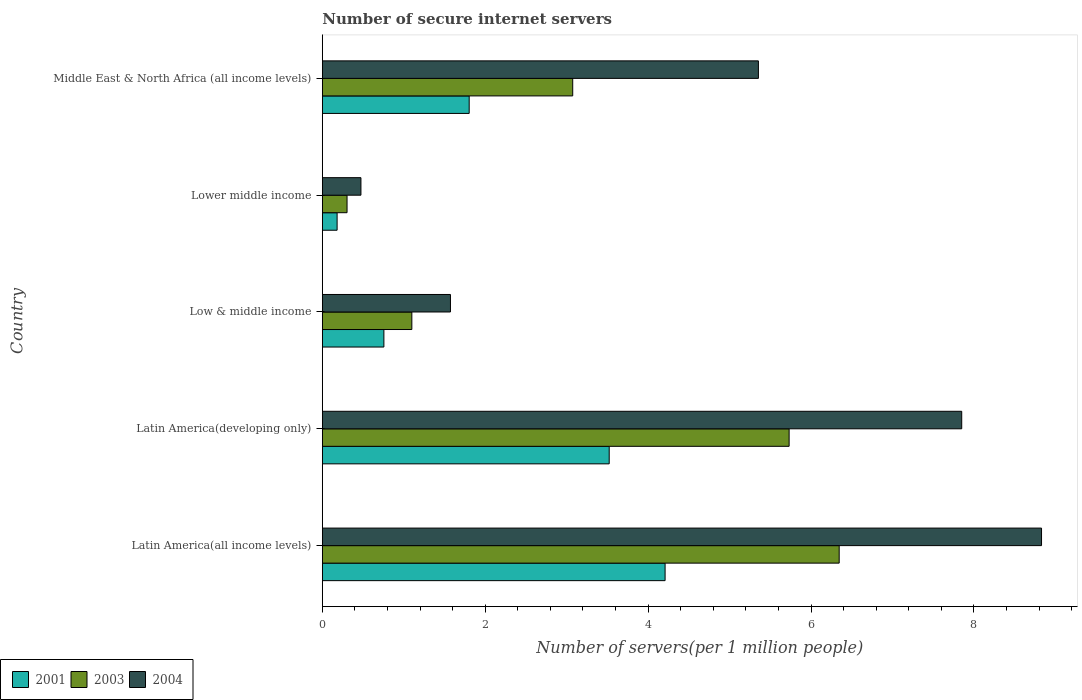How many groups of bars are there?
Provide a succinct answer. 5. Are the number of bars per tick equal to the number of legend labels?
Provide a succinct answer. Yes. Are the number of bars on each tick of the Y-axis equal?
Ensure brevity in your answer.  Yes. How many bars are there on the 3rd tick from the bottom?
Your answer should be compact. 3. What is the label of the 5th group of bars from the top?
Ensure brevity in your answer.  Latin America(all income levels). What is the number of secure internet servers in 2001 in Middle East & North Africa (all income levels)?
Offer a terse response. 1.8. Across all countries, what is the maximum number of secure internet servers in 2004?
Your answer should be compact. 8.83. Across all countries, what is the minimum number of secure internet servers in 2001?
Your answer should be very brief. 0.18. In which country was the number of secure internet servers in 2001 maximum?
Give a very brief answer. Latin America(all income levels). In which country was the number of secure internet servers in 2003 minimum?
Keep it short and to the point. Lower middle income. What is the total number of secure internet servers in 2004 in the graph?
Keep it short and to the point. 24.08. What is the difference between the number of secure internet servers in 2003 in Latin America(all income levels) and that in Latin America(developing only)?
Ensure brevity in your answer.  0.61. What is the difference between the number of secure internet servers in 2003 in Lower middle income and the number of secure internet servers in 2001 in Latin America(developing only)?
Your answer should be very brief. -3.22. What is the average number of secure internet servers in 2001 per country?
Your answer should be very brief. 2.09. What is the difference between the number of secure internet servers in 2004 and number of secure internet servers in 2001 in Low & middle income?
Provide a short and direct response. 0.82. In how many countries, is the number of secure internet servers in 2003 greater than 4 ?
Keep it short and to the point. 2. What is the ratio of the number of secure internet servers in 2001 in Low & middle income to that in Lower middle income?
Offer a very short reply. 4.16. Is the number of secure internet servers in 2003 in Latin America(all income levels) less than that in Lower middle income?
Give a very brief answer. No. Is the difference between the number of secure internet servers in 2004 in Low & middle income and Middle East & North Africa (all income levels) greater than the difference between the number of secure internet servers in 2001 in Low & middle income and Middle East & North Africa (all income levels)?
Provide a succinct answer. No. What is the difference between the highest and the second highest number of secure internet servers in 2003?
Offer a very short reply. 0.61. What is the difference between the highest and the lowest number of secure internet servers in 2004?
Keep it short and to the point. 8.36. Is the sum of the number of secure internet servers in 2004 in Latin America(developing only) and Lower middle income greater than the maximum number of secure internet servers in 2003 across all countries?
Offer a very short reply. Yes. What does the 1st bar from the bottom in Lower middle income represents?
Provide a succinct answer. 2001. Are all the bars in the graph horizontal?
Provide a short and direct response. Yes. Where does the legend appear in the graph?
Provide a short and direct response. Bottom left. How many legend labels are there?
Your answer should be very brief. 3. How are the legend labels stacked?
Ensure brevity in your answer.  Horizontal. What is the title of the graph?
Offer a terse response. Number of secure internet servers. Does "1998" appear as one of the legend labels in the graph?
Give a very brief answer. No. What is the label or title of the X-axis?
Your answer should be very brief. Number of servers(per 1 million people). What is the Number of servers(per 1 million people) of 2001 in Latin America(all income levels)?
Make the answer very short. 4.21. What is the Number of servers(per 1 million people) in 2003 in Latin America(all income levels)?
Your answer should be very brief. 6.35. What is the Number of servers(per 1 million people) of 2004 in Latin America(all income levels)?
Your answer should be compact. 8.83. What is the Number of servers(per 1 million people) in 2001 in Latin America(developing only)?
Provide a short and direct response. 3.52. What is the Number of servers(per 1 million people) in 2003 in Latin America(developing only)?
Provide a short and direct response. 5.73. What is the Number of servers(per 1 million people) of 2004 in Latin America(developing only)?
Give a very brief answer. 7.85. What is the Number of servers(per 1 million people) in 2001 in Low & middle income?
Offer a terse response. 0.76. What is the Number of servers(per 1 million people) of 2003 in Low & middle income?
Your answer should be very brief. 1.1. What is the Number of servers(per 1 million people) of 2004 in Low & middle income?
Offer a very short reply. 1.57. What is the Number of servers(per 1 million people) of 2001 in Lower middle income?
Offer a very short reply. 0.18. What is the Number of servers(per 1 million people) of 2003 in Lower middle income?
Make the answer very short. 0.3. What is the Number of servers(per 1 million people) in 2004 in Lower middle income?
Your answer should be very brief. 0.47. What is the Number of servers(per 1 million people) in 2001 in Middle East & North Africa (all income levels)?
Make the answer very short. 1.8. What is the Number of servers(per 1 million people) of 2003 in Middle East & North Africa (all income levels)?
Make the answer very short. 3.07. What is the Number of servers(per 1 million people) in 2004 in Middle East & North Africa (all income levels)?
Your answer should be very brief. 5.35. Across all countries, what is the maximum Number of servers(per 1 million people) of 2001?
Give a very brief answer. 4.21. Across all countries, what is the maximum Number of servers(per 1 million people) of 2003?
Ensure brevity in your answer.  6.35. Across all countries, what is the maximum Number of servers(per 1 million people) of 2004?
Keep it short and to the point. 8.83. Across all countries, what is the minimum Number of servers(per 1 million people) of 2001?
Offer a terse response. 0.18. Across all countries, what is the minimum Number of servers(per 1 million people) in 2003?
Provide a short and direct response. 0.3. Across all countries, what is the minimum Number of servers(per 1 million people) in 2004?
Your answer should be very brief. 0.47. What is the total Number of servers(per 1 million people) in 2001 in the graph?
Offer a terse response. 10.47. What is the total Number of servers(per 1 million people) of 2003 in the graph?
Ensure brevity in your answer.  16.55. What is the total Number of servers(per 1 million people) in 2004 in the graph?
Provide a short and direct response. 24.08. What is the difference between the Number of servers(per 1 million people) in 2001 in Latin America(all income levels) and that in Latin America(developing only)?
Keep it short and to the point. 0.69. What is the difference between the Number of servers(per 1 million people) of 2003 in Latin America(all income levels) and that in Latin America(developing only)?
Give a very brief answer. 0.61. What is the difference between the Number of servers(per 1 million people) in 2004 in Latin America(all income levels) and that in Latin America(developing only)?
Your answer should be compact. 0.98. What is the difference between the Number of servers(per 1 million people) of 2001 in Latin America(all income levels) and that in Low & middle income?
Make the answer very short. 3.45. What is the difference between the Number of servers(per 1 million people) in 2003 in Latin America(all income levels) and that in Low & middle income?
Ensure brevity in your answer.  5.25. What is the difference between the Number of servers(per 1 million people) of 2004 in Latin America(all income levels) and that in Low & middle income?
Make the answer very short. 7.26. What is the difference between the Number of servers(per 1 million people) in 2001 in Latin America(all income levels) and that in Lower middle income?
Provide a short and direct response. 4.03. What is the difference between the Number of servers(per 1 million people) in 2003 in Latin America(all income levels) and that in Lower middle income?
Your answer should be very brief. 6.04. What is the difference between the Number of servers(per 1 million people) in 2004 in Latin America(all income levels) and that in Lower middle income?
Keep it short and to the point. 8.36. What is the difference between the Number of servers(per 1 million people) of 2001 in Latin America(all income levels) and that in Middle East & North Africa (all income levels)?
Keep it short and to the point. 2.41. What is the difference between the Number of servers(per 1 million people) in 2003 in Latin America(all income levels) and that in Middle East & North Africa (all income levels)?
Offer a terse response. 3.27. What is the difference between the Number of servers(per 1 million people) in 2004 in Latin America(all income levels) and that in Middle East & North Africa (all income levels)?
Your answer should be very brief. 3.48. What is the difference between the Number of servers(per 1 million people) in 2001 in Latin America(developing only) and that in Low & middle income?
Keep it short and to the point. 2.77. What is the difference between the Number of servers(per 1 million people) of 2003 in Latin America(developing only) and that in Low & middle income?
Make the answer very short. 4.63. What is the difference between the Number of servers(per 1 million people) in 2004 in Latin America(developing only) and that in Low & middle income?
Ensure brevity in your answer.  6.28. What is the difference between the Number of servers(per 1 million people) of 2001 in Latin America(developing only) and that in Lower middle income?
Offer a very short reply. 3.34. What is the difference between the Number of servers(per 1 million people) in 2003 in Latin America(developing only) and that in Lower middle income?
Offer a very short reply. 5.43. What is the difference between the Number of servers(per 1 million people) of 2004 in Latin America(developing only) and that in Lower middle income?
Provide a short and direct response. 7.38. What is the difference between the Number of servers(per 1 million people) in 2001 in Latin America(developing only) and that in Middle East & North Africa (all income levels)?
Give a very brief answer. 1.72. What is the difference between the Number of servers(per 1 million people) of 2003 in Latin America(developing only) and that in Middle East & North Africa (all income levels)?
Your answer should be very brief. 2.66. What is the difference between the Number of servers(per 1 million people) of 2004 in Latin America(developing only) and that in Middle East & North Africa (all income levels)?
Provide a succinct answer. 2.5. What is the difference between the Number of servers(per 1 million people) of 2001 in Low & middle income and that in Lower middle income?
Keep it short and to the point. 0.57. What is the difference between the Number of servers(per 1 million people) of 2003 in Low & middle income and that in Lower middle income?
Keep it short and to the point. 0.8. What is the difference between the Number of servers(per 1 million people) of 2004 in Low & middle income and that in Lower middle income?
Ensure brevity in your answer.  1.1. What is the difference between the Number of servers(per 1 million people) in 2001 in Low & middle income and that in Middle East & North Africa (all income levels)?
Provide a short and direct response. -1.05. What is the difference between the Number of servers(per 1 million people) of 2003 in Low & middle income and that in Middle East & North Africa (all income levels)?
Give a very brief answer. -1.98. What is the difference between the Number of servers(per 1 million people) in 2004 in Low & middle income and that in Middle East & North Africa (all income levels)?
Provide a short and direct response. -3.78. What is the difference between the Number of servers(per 1 million people) in 2001 in Lower middle income and that in Middle East & North Africa (all income levels)?
Give a very brief answer. -1.62. What is the difference between the Number of servers(per 1 million people) in 2003 in Lower middle income and that in Middle East & North Africa (all income levels)?
Give a very brief answer. -2.77. What is the difference between the Number of servers(per 1 million people) in 2004 in Lower middle income and that in Middle East & North Africa (all income levels)?
Provide a succinct answer. -4.88. What is the difference between the Number of servers(per 1 million people) of 2001 in Latin America(all income levels) and the Number of servers(per 1 million people) of 2003 in Latin America(developing only)?
Your answer should be compact. -1.52. What is the difference between the Number of servers(per 1 million people) in 2001 in Latin America(all income levels) and the Number of servers(per 1 million people) in 2004 in Latin America(developing only)?
Provide a succinct answer. -3.64. What is the difference between the Number of servers(per 1 million people) in 2003 in Latin America(all income levels) and the Number of servers(per 1 million people) in 2004 in Latin America(developing only)?
Offer a terse response. -1.5. What is the difference between the Number of servers(per 1 million people) in 2001 in Latin America(all income levels) and the Number of servers(per 1 million people) in 2003 in Low & middle income?
Provide a short and direct response. 3.11. What is the difference between the Number of servers(per 1 million people) of 2001 in Latin America(all income levels) and the Number of servers(per 1 million people) of 2004 in Low & middle income?
Offer a terse response. 2.64. What is the difference between the Number of servers(per 1 million people) of 2003 in Latin America(all income levels) and the Number of servers(per 1 million people) of 2004 in Low & middle income?
Keep it short and to the point. 4.77. What is the difference between the Number of servers(per 1 million people) in 2001 in Latin America(all income levels) and the Number of servers(per 1 million people) in 2003 in Lower middle income?
Provide a succinct answer. 3.91. What is the difference between the Number of servers(per 1 million people) of 2001 in Latin America(all income levels) and the Number of servers(per 1 million people) of 2004 in Lower middle income?
Your answer should be compact. 3.73. What is the difference between the Number of servers(per 1 million people) of 2003 in Latin America(all income levels) and the Number of servers(per 1 million people) of 2004 in Lower middle income?
Give a very brief answer. 5.87. What is the difference between the Number of servers(per 1 million people) of 2001 in Latin America(all income levels) and the Number of servers(per 1 million people) of 2003 in Middle East & North Africa (all income levels)?
Provide a succinct answer. 1.13. What is the difference between the Number of servers(per 1 million people) in 2001 in Latin America(all income levels) and the Number of servers(per 1 million people) in 2004 in Middle East & North Africa (all income levels)?
Keep it short and to the point. -1.15. What is the difference between the Number of servers(per 1 million people) in 2003 in Latin America(all income levels) and the Number of servers(per 1 million people) in 2004 in Middle East & North Africa (all income levels)?
Your answer should be very brief. 0.99. What is the difference between the Number of servers(per 1 million people) in 2001 in Latin America(developing only) and the Number of servers(per 1 million people) in 2003 in Low & middle income?
Give a very brief answer. 2.42. What is the difference between the Number of servers(per 1 million people) of 2001 in Latin America(developing only) and the Number of servers(per 1 million people) of 2004 in Low & middle income?
Give a very brief answer. 1.95. What is the difference between the Number of servers(per 1 million people) in 2003 in Latin America(developing only) and the Number of servers(per 1 million people) in 2004 in Low & middle income?
Your response must be concise. 4.16. What is the difference between the Number of servers(per 1 million people) of 2001 in Latin America(developing only) and the Number of servers(per 1 million people) of 2003 in Lower middle income?
Your response must be concise. 3.22. What is the difference between the Number of servers(per 1 million people) of 2001 in Latin America(developing only) and the Number of servers(per 1 million people) of 2004 in Lower middle income?
Make the answer very short. 3.05. What is the difference between the Number of servers(per 1 million people) of 2003 in Latin America(developing only) and the Number of servers(per 1 million people) of 2004 in Lower middle income?
Provide a succinct answer. 5.26. What is the difference between the Number of servers(per 1 million people) of 2001 in Latin America(developing only) and the Number of servers(per 1 million people) of 2003 in Middle East & North Africa (all income levels)?
Your answer should be very brief. 0.45. What is the difference between the Number of servers(per 1 million people) of 2001 in Latin America(developing only) and the Number of servers(per 1 million people) of 2004 in Middle East & North Africa (all income levels)?
Your response must be concise. -1.83. What is the difference between the Number of servers(per 1 million people) in 2003 in Latin America(developing only) and the Number of servers(per 1 million people) in 2004 in Middle East & North Africa (all income levels)?
Offer a terse response. 0.38. What is the difference between the Number of servers(per 1 million people) in 2001 in Low & middle income and the Number of servers(per 1 million people) in 2003 in Lower middle income?
Make the answer very short. 0.45. What is the difference between the Number of servers(per 1 million people) of 2001 in Low & middle income and the Number of servers(per 1 million people) of 2004 in Lower middle income?
Ensure brevity in your answer.  0.28. What is the difference between the Number of servers(per 1 million people) in 2003 in Low & middle income and the Number of servers(per 1 million people) in 2004 in Lower middle income?
Your response must be concise. 0.62. What is the difference between the Number of servers(per 1 million people) of 2001 in Low & middle income and the Number of servers(per 1 million people) of 2003 in Middle East & North Africa (all income levels)?
Offer a very short reply. -2.32. What is the difference between the Number of servers(per 1 million people) of 2001 in Low & middle income and the Number of servers(per 1 million people) of 2004 in Middle East & North Africa (all income levels)?
Give a very brief answer. -4.6. What is the difference between the Number of servers(per 1 million people) of 2003 in Low & middle income and the Number of servers(per 1 million people) of 2004 in Middle East & North Africa (all income levels)?
Your answer should be very brief. -4.26. What is the difference between the Number of servers(per 1 million people) in 2001 in Lower middle income and the Number of servers(per 1 million people) in 2003 in Middle East & North Africa (all income levels)?
Your answer should be compact. -2.89. What is the difference between the Number of servers(per 1 million people) of 2001 in Lower middle income and the Number of servers(per 1 million people) of 2004 in Middle East & North Africa (all income levels)?
Your answer should be compact. -5.17. What is the difference between the Number of servers(per 1 million people) in 2003 in Lower middle income and the Number of servers(per 1 million people) in 2004 in Middle East & North Africa (all income levels)?
Offer a very short reply. -5.05. What is the average Number of servers(per 1 million people) of 2001 per country?
Your response must be concise. 2.09. What is the average Number of servers(per 1 million people) of 2003 per country?
Offer a very short reply. 3.31. What is the average Number of servers(per 1 million people) in 2004 per country?
Offer a very short reply. 4.82. What is the difference between the Number of servers(per 1 million people) in 2001 and Number of servers(per 1 million people) in 2003 in Latin America(all income levels)?
Provide a succinct answer. -2.14. What is the difference between the Number of servers(per 1 million people) of 2001 and Number of servers(per 1 million people) of 2004 in Latin America(all income levels)?
Give a very brief answer. -4.62. What is the difference between the Number of servers(per 1 million people) in 2003 and Number of servers(per 1 million people) in 2004 in Latin America(all income levels)?
Offer a terse response. -2.48. What is the difference between the Number of servers(per 1 million people) of 2001 and Number of servers(per 1 million people) of 2003 in Latin America(developing only)?
Make the answer very short. -2.21. What is the difference between the Number of servers(per 1 million people) of 2001 and Number of servers(per 1 million people) of 2004 in Latin America(developing only)?
Your answer should be compact. -4.33. What is the difference between the Number of servers(per 1 million people) in 2003 and Number of servers(per 1 million people) in 2004 in Latin America(developing only)?
Your answer should be compact. -2.12. What is the difference between the Number of servers(per 1 million people) of 2001 and Number of servers(per 1 million people) of 2003 in Low & middle income?
Offer a terse response. -0.34. What is the difference between the Number of servers(per 1 million people) of 2001 and Number of servers(per 1 million people) of 2004 in Low & middle income?
Your response must be concise. -0.82. What is the difference between the Number of servers(per 1 million people) of 2003 and Number of servers(per 1 million people) of 2004 in Low & middle income?
Your answer should be compact. -0.47. What is the difference between the Number of servers(per 1 million people) in 2001 and Number of servers(per 1 million people) in 2003 in Lower middle income?
Make the answer very short. -0.12. What is the difference between the Number of servers(per 1 million people) in 2001 and Number of servers(per 1 million people) in 2004 in Lower middle income?
Give a very brief answer. -0.29. What is the difference between the Number of servers(per 1 million people) in 2003 and Number of servers(per 1 million people) in 2004 in Lower middle income?
Your answer should be very brief. -0.17. What is the difference between the Number of servers(per 1 million people) of 2001 and Number of servers(per 1 million people) of 2003 in Middle East & North Africa (all income levels)?
Your response must be concise. -1.27. What is the difference between the Number of servers(per 1 million people) in 2001 and Number of servers(per 1 million people) in 2004 in Middle East & North Africa (all income levels)?
Offer a terse response. -3.55. What is the difference between the Number of servers(per 1 million people) in 2003 and Number of servers(per 1 million people) in 2004 in Middle East & North Africa (all income levels)?
Give a very brief answer. -2.28. What is the ratio of the Number of servers(per 1 million people) in 2001 in Latin America(all income levels) to that in Latin America(developing only)?
Your response must be concise. 1.19. What is the ratio of the Number of servers(per 1 million people) of 2003 in Latin America(all income levels) to that in Latin America(developing only)?
Provide a succinct answer. 1.11. What is the ratio of the Number of servers(per 1 million people) of 2004 in Latin America(all income levels) to that in Latin America(developing only)?
Offer a terse response. 1.12. What is the ratio of the Number of servers(per 1 million people) in 2001 in Latin America(all income levels) to that in Low & middle income?
Keep it short and to the point. 5.57. What is the ratio of the Number of servers(per 1 million people) of 2003 in Latin America(all income levels) to that in Low & middle income?
Give a very brief answer. 5.77. What is the ratio of the Number of servers(per 1 million people) in 2004 in Latin America(all income levels) to that in Low & middle income?
Provide a short and direct response. 5.61. What is the ratio of the Number of servers(per 1 million people) of 2001 in Latin America(all income levels) to that in Lower middle income?
Keep it short and to the point. 23.18. What is the ratio of the Number of servers(per 1 million people) in 2003 in Latin America(all income levels) to that in Lower middle income?
Offer a terse response. 20.91. What is the ratio of the Number of servers(per 1 million people) in 2004 in Latin America(all income levels) to that in Lower middle income?
Ensure brevity in your answer.  18.63. What is the ratio of the Number of servers(per 1 million people) in 2001 in Latin America(all income levels) to that in Middle East & North Africa (all income levels)?
Offer a very short reply. 2.33. What is the ratio of the Number of servers(per 1 million people) in 2003 in Latin America(all income levels) to that in Middle East & North Africa (all income levels)?
Provide a short and direct response. 2.06. What is the ratio of the Number of servers(per 1 million people) in 2004 in Latin America(all income levels) to that in Middle East & North Africa (all income levels)?
Give a very brief answer. 1.65. What is the ratio of the Number of servers(per 1 million people) in 2001 in Latin America(developing only) to that in Low & middle income?
Your answer should be compact. 4.66. What is the ratio of the Number of servers(per 1 million people) in 2003 in Latin America(developing only) to that in Low & middle income?
Offer a very short reply. 5.21. What is the ratio of the Number of servers(per 1 million people) in 2004 in Latin America(developing only) to that in Low & middle income?
Your response must be concise. 4.99. What is the ratio of the Number of servers(per 1 million people) in 2001 in Latin America(developing only) to that in Lower middle income?
Offer a very short reply. 19.4. What is the ratio of the Number of servers(per 1 million people) in 2003 in Latin America(developing only) to that in Lower middle income?
Make the answer very short. 18.89. What is the ratio of the Number of servers(per 1 million people) of 2004 in Latin America(developing only) to that in Lower middle income?
Provide a succinct answer. 16.56. What is the ratio of the Number of servers(per 1 million people) of 2001 in Latin America(developing only) to that in Middle East & North Africa (all income levels)?
Your answer should be very brief. 1.95. What is the ratio of the Number of servers(per 1 million people) in 2003 in Latin America(developing only) to that in Middle East & North Africa (all income levels)?
Make the answer very short. 1.86. What is the ratio of the Number of servers(per 1 million people) in 2004 in Latin America(developing only) to that in Middle East & North Africa (all income levels)?
Offer a terse response. 1.47. What is the ratio of the Number of servers(per 1 million people) of 2001 in Low & middle income to that in Lower middle income?
Your answer should be compact. 4.16. What is the ratio of the Number of servers(per 1 million people) of 2003 in Low & middle income to that in Lower middle income?
Your answer should be very brief. 3.62. What is the ratio of the Number of servers(per 1 million people) in 2004 in Low & middle income to that in Lower middle income?
Offer a very short reply. 3.32. What is the ratio of the Number of servers(per 1 million people) of 2001 in Low & middle income to that in Middle East & North Africa (all income levels)?
Make the answer very short. 0.42. What is the ratio of the Number of servers(per 1 million people) of 2003 in Low & middle income to that in Middle East & North Africa (all income levels)?
Provide a succinct answer. 0.36. What is the ratio of the Number of servers(per 1 million people) of 2004 in Low & middle income to that in Middle East & North Africa (all income levels)?
Make the answer very short. 0.29. What is the ratio of the Number of servers(per 1 million people) of 2001 in Lower middle income to that in Middle East & North Africa (all income levels)?
Provide a short and direct response. 0.1. What is the ratio of the Number of servers(per 1 million people) of 2003 in Lower middle income to that in Middle East & North Africa (all income levels)?
Keep it short and to the point. 0.1. What is the ratio of the Number of servers(per 1 million people) of 2004 in Lower middle income to that in Middle East & North Africa (all income levels)?
Keep it short and to the point. 0.09. What is the difference between the highest and the second highest Number of servers(per 1 million people) in 2001?
Your answer should be very brief. 0.69. What is the difference between the highest and the second highest Number of servers(per 1 million people) in 2003?
Provide a short and direct response. 0.61. What is the difference between the highest and the second highest Number of servers(per 1 million people) in 2004?
Offer a very short reply. 0.98. What is the difference between the highest and the lowest Number of servers(per 1 million people) in 2001?
Offer a very short reply. 4.03. What is the difference between the highest and the lowest Number of servers(per 1 million people) of 2003?
Provide a succinct answer. 6.04. What is the difference between the highest and the lowest Number of servers(per 1 million people) in 2004?
Provide a short and direct response. 8.36. 